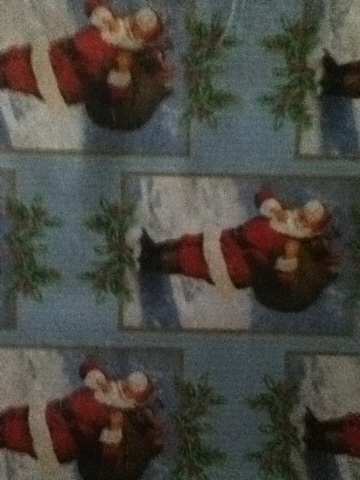Describe a nostalgic holiday memory that this wrapping paper might invoke for someone. This wrapping paper might invoke a nostalgic memory of waking up early on Christmas morning, filled with the excitement of finding what Santa left under the tree. The sight of the wrapping paper might bring back the memory of eagerly tearing it open to reveal a beloved toy or a long-awaited gift. The festive design could remind someone of family gatherings, the joy of seeing loved ones' reactions as they open their gifts, the warmth of a cozy home filled with laughter and holiday cheer, and perhaps the scent of freshly baked cookies lingering in the air. All these elements combine to create a cherished recollection of a perfect Christmas morning. 